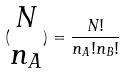Convert formula to latex. <formula><loc_0><loc_0><loc_500><loc_500>( \begin{matrix} N \\ n _ { A } \end{matrix} ) = \frac { N ! } { n _ { A } ! n _ { B } ! }</formula> 